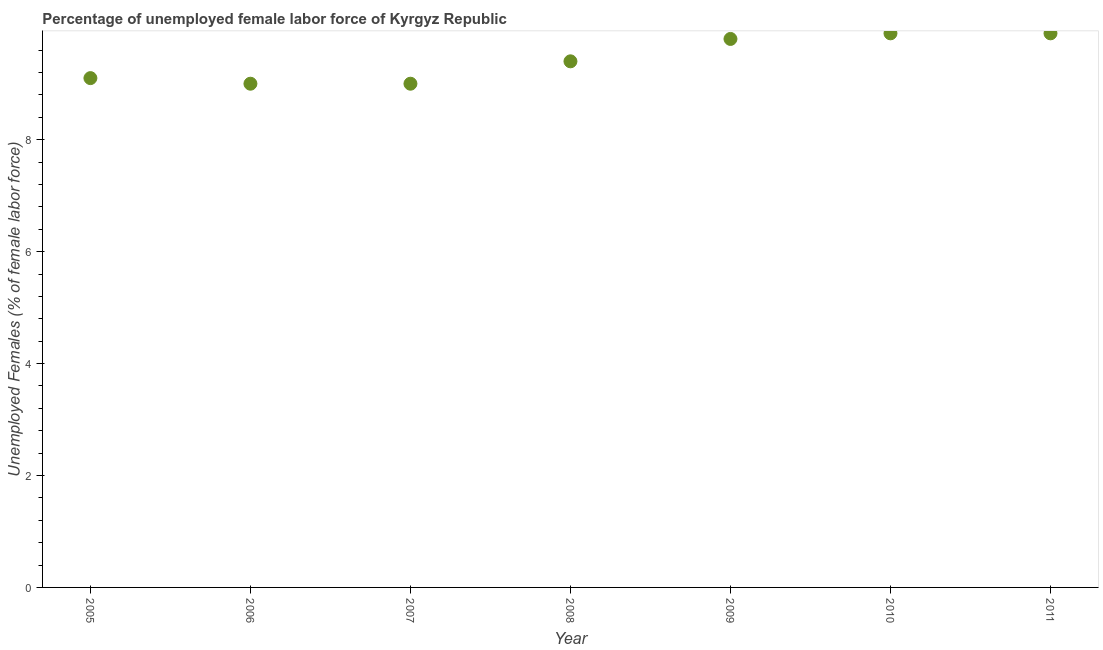What is the total unemployed female labour force in 2009?
Your answer should be very brief. 9.8. Across all years, what is the maximum total unemployed female labour force?
Your answer should be very brief. 9.9. Across all years, what is the minimum total unemployed female labour force?
Your response must be concise. 9. In which year was the total unemployed female labour force maximum?
Offer a very short reply. 2010. In which year was the total unemployed female labour force minimum?
Your response must be concise. 2006. What is the sum of the total unemployed female labour force?
Offer a very short reply. 66.1. What is the difference between the total unemployed female labour force in 2007 and 2009?
Your answer should be compact. -0.8. What is the average total unemployed female labour force per year?
Offer a terse response. 9.44. What is the median total unemployed female labour force?
Provide a succinct answer. 9.4. What is the ratio of the total unemployed female labour force in 2005 to that in 2010?
Your response must be concise. 0.92. Is the total unemployed female labour force in 2006 less than that in 2007?
Offer a very short reply. No. Is the difference between the total unemployed female labour force in 2008 and 2010 greater than the difference between any two years?
Make the answer very short. No. What is the difference between the highest and the second highest total unemployed female labour force?
Offer a terse response. 0. What is the difference between the highest and the lowest total unemployed female labour force?
Offer a very short reply. 0.9. How many years are there in the graph?
Offer a terse response. 7. What is the difference between two consecutive major ticks on the Y-axis?
Your answer should be very brief. 2. What is the title of the graph?
Make the answer very short. Percentage of unemployed female labor force of Kyrgyz Republic. What is the label or title of the X-axis?
Your answer should be compact. Year. What is the label or title of the Y-axis?
Your answer should be compact. Unemployed Females (% of female labor force). What is the Unemployed Females (% of female labor force) in 2005?
Ensure brevity in your answer.  9.1. What is the Unemployed Females (% of female labor force) in 2008?
Your response must be concise. 9.4. What is the Unemployed Females (% of female labor force) in 2009?
Your answer should be compact. 9.8. What is the Unemployed Females (% of female labor force) in 2010?
Provide a short and direct response. 9.9. What is the Unemployed Females (% of female labor force) in 2011?
Your answer should be very brief. 9.9. What is the difference between the Unemployed Females (% of female labor force) in 2005 and 2007?
Offer a terse response. 0.1. What is the difference between the Unemployed Females (% of female labor force) in 2005 and 2009?
Give a very brief answer. -0.7. What is the difference between the Unemployed Females (% of female labor force) in 2006 and 2009?
Make the answer very short. -0.8. What is the difference between the Unemployed Females (% of female labor force) in 2007 and 2008?
Keep it short and to the point. -0.4. What is the difference between the Unemployed Females (% of female labor force) in 2008 and 2010?
Your answer should be very brief. -0.5. What is the difference between the Unemployed Females (% of female labor force) in 2008 and 2011?
Make the answer very short. -0.5. What is the difference between the Unemployed Females (% of female labor force) in 2009 and 2011?
Your answer should be compact. -0.1. What is the difference between the Unemployed Females (% of female labor force) in 2010 and 2011?
Give a very brief answer. 0. What is the ratio of the Unemployed Females (% of female labor force) in 2005 to that in 2008?
Ensure brevity in your answer.  0.97. What is the ratio of the Unemployed Females (% of female labor force) in 2005 to that in 2009?
Ensure brevity in your answer.  0.93. What is the ratio of the Unemployed Females (% of female labor force) in 2005 to that in 2010?
Offer a terse response. 0.92. What is the ratio of the Unemployed Females (% of female labor force) in 2005 to that in 2011?
Make the answer very short. 0.92. What is the ratio of the Unemployed Females (% of female labor force) in 2006 to that in 2008?
Make the answer very short. 0.96. What is the ratio of the Unemployed Females (% of female labor force) in 2006 to that in 2009?
Ensure brevity in your answer.  0.92. What is the ratio of the Unemployed Females (% of female labor force) in 2006 to that in 2010?
Your answer should be compact. 0.91. What is the ratio of the Unemployed Females (% of female labor force) in 2006 to that in 2011?
Give a very brief answer. 0.91. What is the ratio of the Unemployed Females (% of female labor force) in 2007 to that in 2008?
Give a very brief answer. 0.96. What is the ratio of the Unemployed Females (% of female labor force) in 2007 to that in 2009?
Give a very brief answer. 0.92. What is the ratio of the Unemployed Females (% of female labor force) in 2007 to that in 2010?
Provide a short and direct response. 0.91. What is the ratio of the Unemployed Females (% of female labor force) in 2007 to that in 2011?
Your answer should be compact. 0.91. What is the ratio of the Unemployed Females (% of female labor force) in 2008 to that in 2010?
Provide a succinct answer. 0.95. What is the ratio of the Unemployed Females (% of female labor force) in 2008 to that in 2011?
Make the answer very short. 0.95. What is the ratio of the Unemployed Females (% of female labor force) in 2009 to that in 2010?
Ensure brevity in your answer.  0.99. What is the ratio of the Unemployed Females (% of female labor force) in 2009 to that in 2011?
Keep it short and to the point. 0.99. What is the ratio of the Unemployed Females (% of female labor force) in 2010 to that in 2011?
Provide a succinct answer. 1. 